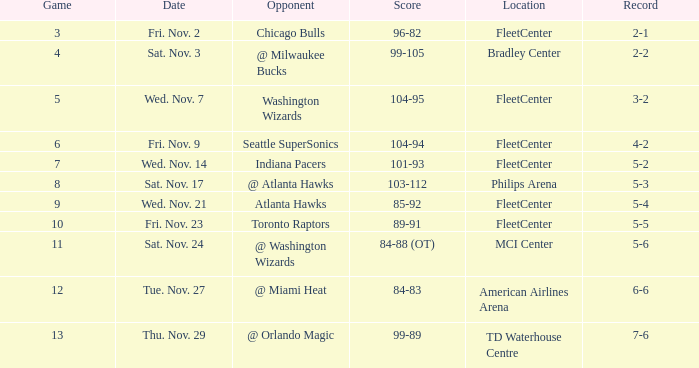How many games have a score of 85-92? 1.0. 